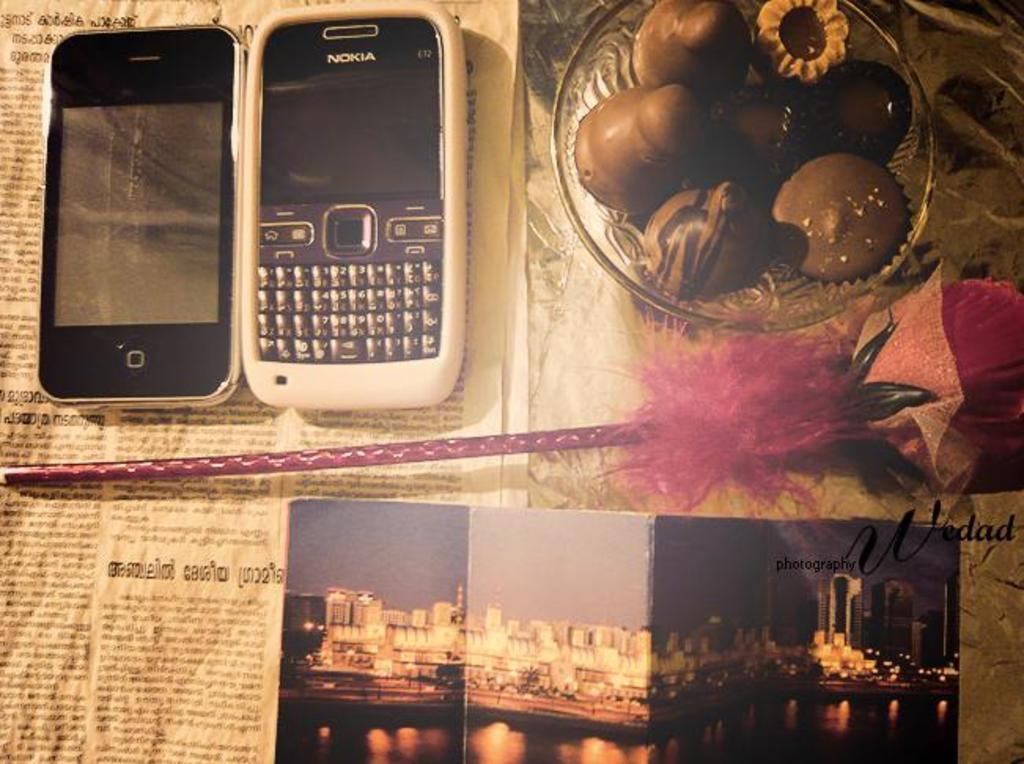<image>
Present a compact description of the photo's key features. the number 2 is on the phone with many other keys on it 